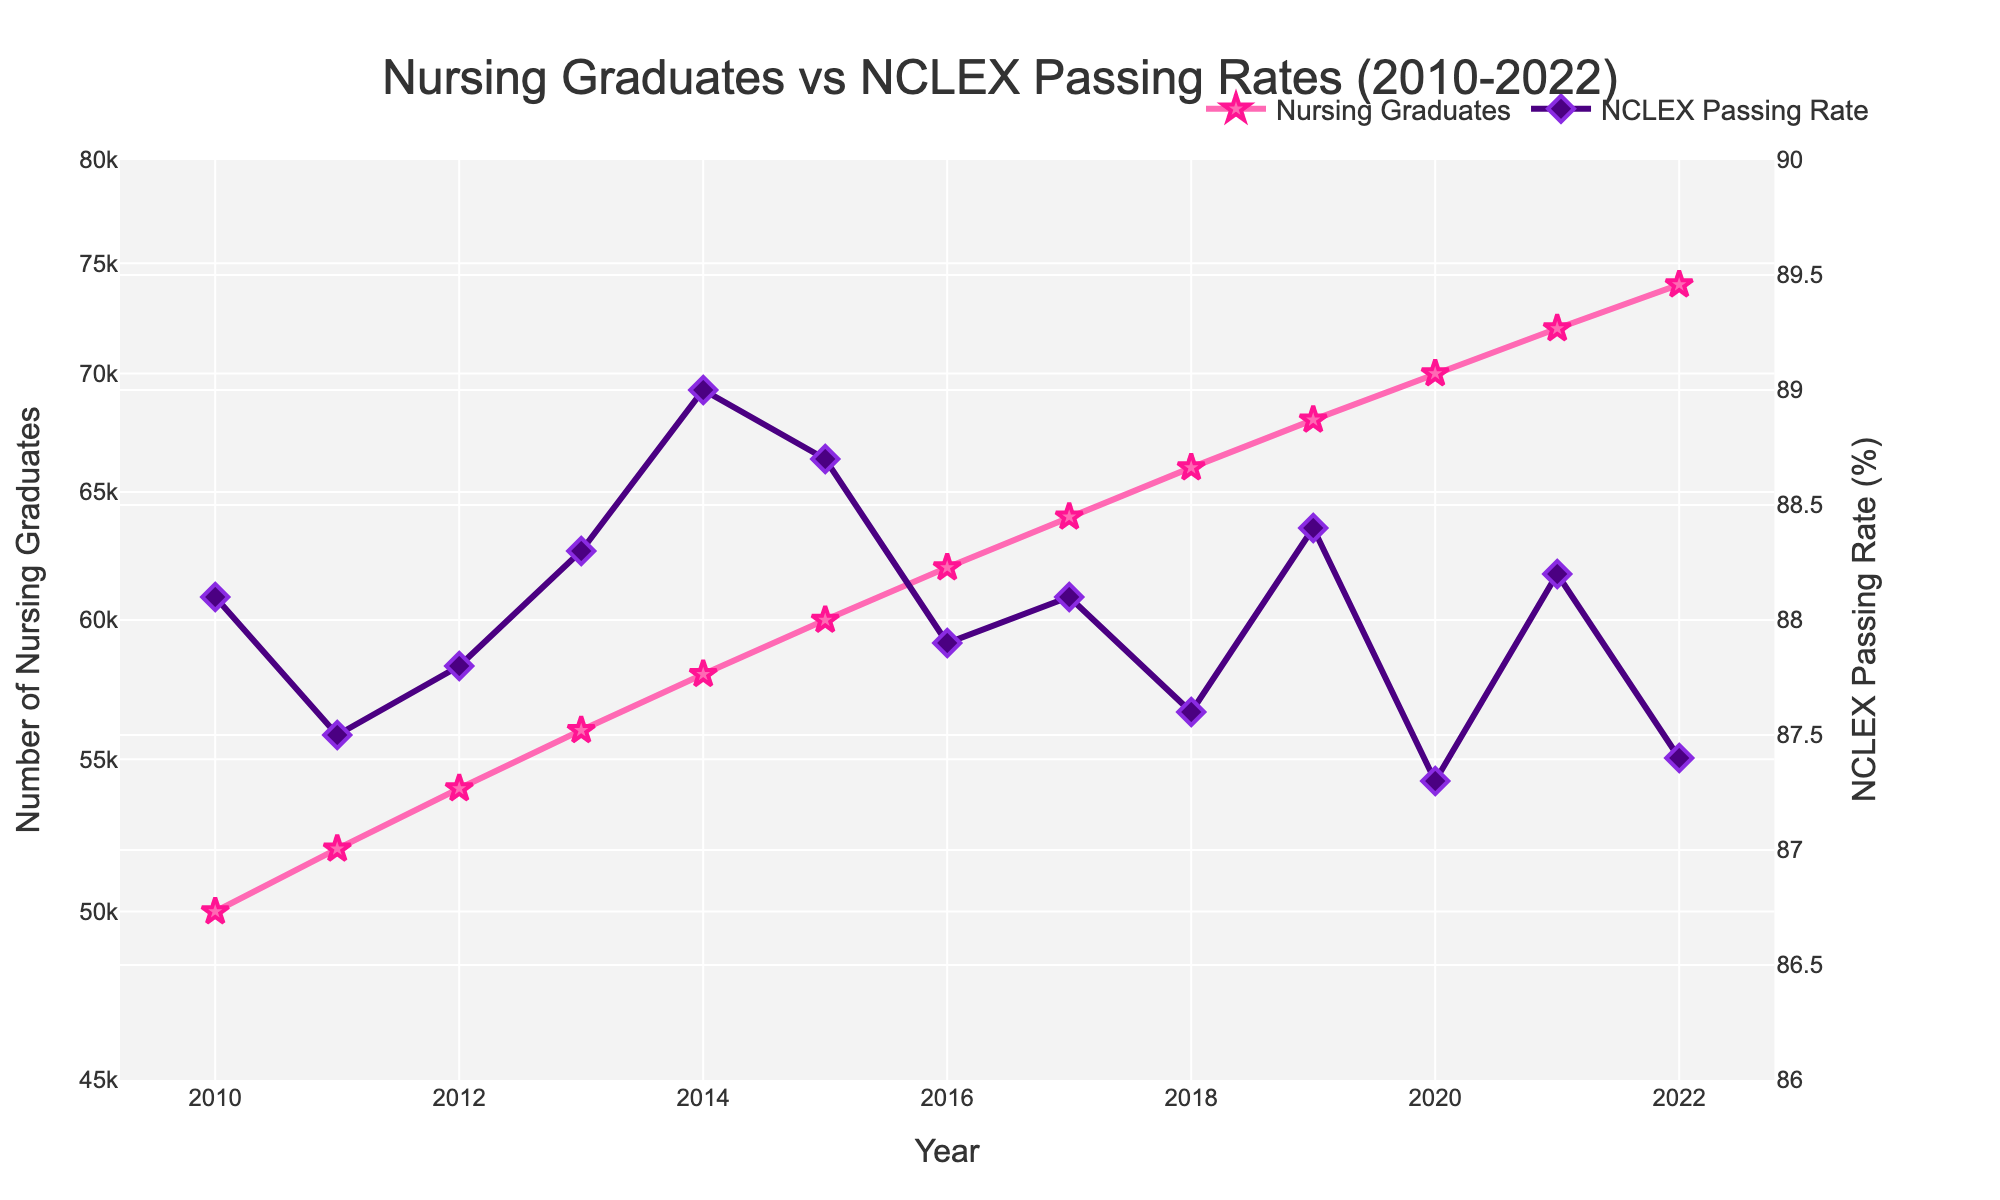What is the title of the figure? The title is located at the top of the figure and is centrally aligned. It helps in understanding the context of the plot. The title reads "Nursing Graduates vs NCLEX Passing Rates (2010-2022)."
Answer: Nursing Graduates vs NCLEX Passing Rates (2010-2022) What color represents the Number of Nursing Graduates in the plot? The plot uses distinct colors for different data sets. The line and markers representing the Number of Nursing Graduates are colored in a shade of pink (#FF69B4).
Answer: Pink Which year had the highest NCLEX Passing Rate? By observing the y-axis for NCLEX Passing Rate and identifying the diamond marker that reaches the highest point, we can find that the year with the highest NCLEX Passing Rate is 2014 with a rate of 89.0%.
Answer: 2014 Has the Number of Nursing Graduates increased or decreased over the years? By examining the trend of the line and markers on the Number of Nursing Graduates data, we can see that although there might be minor fluctuations, the overall trend is upward from 2010 to 2022.
Answer: Increased Which year had the lowest Number of Nursing Graduates, and what was the value? The log scale on the primary y-axis might make it more challenging to interpret the exact lowest value, but by locating the point with the lowest position on the vertical axis, it's clear that 2010 had the lowest Number of Nursing Graduates, which was 50,000.
Answer: 2010 with 50,000 What is the difference in NCLEX Passing Rate between 2020 and 2021? To find the difference, identify the values for NCLEX Passing Rate in 2020 and 2021, which are 87.3% and 88.2%, respectively. Subtract the lower value from the higher one: 88.2% - 87.3% = 0.9%.
Answer: 0.9% How many data points are there in the plot? Each year from 2010 to 2022 represents a single data point. Counting these years, we find that there are 13 data points.
Answer: 13 Between which consecutive years did the Number of Nursing Graduates see the highest increase? Calculate the increase in the Number of Nursing Graduates between each consecutive year and identify the pair with the largest difference. The difference between 2019 and 2020 (70,000 - 68,000) is 2,000, which is the highest increase in this plot.
Answer: 2019-2020 What was the NCLEX Passing Rate in 2012? Locate the data point corresponding to 2012 on the secondary y-axis for NCLEX Passing Rate. The passing rate for that year is marked at 87.8%.
Answer: 87.8% How does the scale of the y-axis for the Number of Nursing Graduates affect the interpretation of the data? Using a log scale on the y-axis for the Number of Nursing Graduates compresses the range, making it easier to visualize trends over a wide range of values. It can make gradual increases appear less steep and highlight proportional rather than absolute changes.
Answer: Highlights proportional changes 